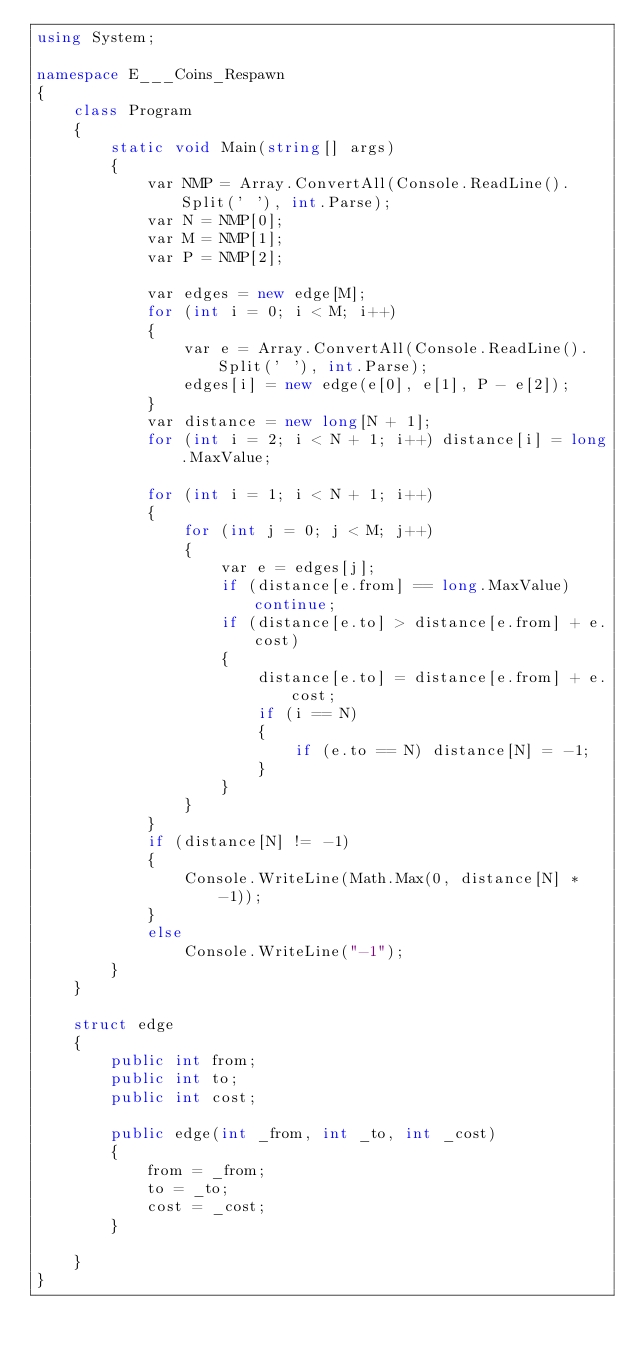<code> <loc_0><loc_0><loc_500><loc_500><_C#_>using System;

namespace E___Coins_Respawn
{
    class Program
    {
        static void Main(string[] args)
        {
            var NMP = Array.ConvertAll(Console.ReadLine().Split(' '), int.Parse);
            var N = NMP[0];
            var M = NMP[1];
            var P = NMP[2];

            var edges = new edge[M];
            for (int i = 0; i < M; i++)
            {
                var e = Array.ConvertAll(Console.ReadLine().Split(' '), int.Parse);
                edges[i] = new edge(e[0], e[1], P - e[2]);
            }
            var distance = new long[N + 1];
            for (int i = 2; i < N + 1; i++) distance[i] = long.MaxValue;

            for (int i = 1; i < N + 1; i++)
            {
                for (int j = 0; j < M; j++)
                {
                    var e = edges[j];
                    if (distance[e.from] == long.MaxValue) continue;
                    if (distance[e.to] > distance[e.from] + e.cost)
                    {
                        distance[e.to] = distance[e.from] + e.cost;
                        if (i == N)
                        {
                            if (e.to == N) distance[N] = -1;
                        }
                    }
                }
            }
            if (distance[N] != -1)
            {
                Console.WriteLine(Math.Max(0, distance[N] * -1));
            }
            else
                Console.WriteLine("-1");
        }
    }

    struct edge
    {
        public int from;
        public int to;
        public int cost;

        public edge(int _from, int _to, int _cost)
        {
            from = _from;
            to = _to;
            cost = _cost;
        }

    }
}
</code> 